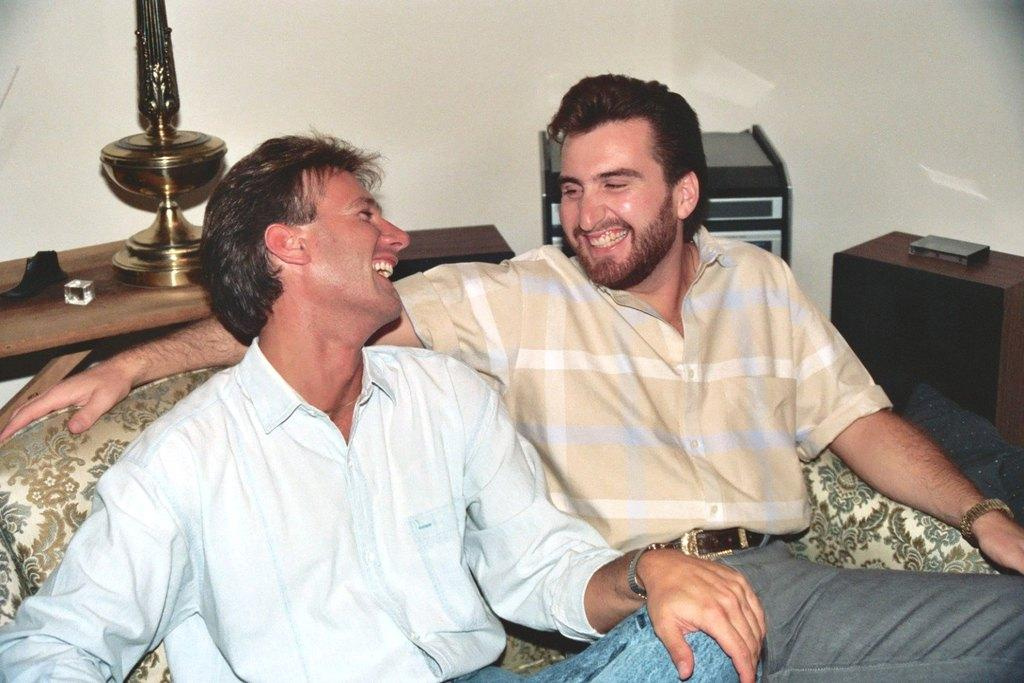How many people are in the image? There are two men in the image. What are the men doing in the image? The men are sitting on a sofa and smiling. What is on the table in the image? There are dice on the table. What can be seen in the background of the image? There is a wall in the background of the image. What type of battle is taking place in the image? There is no battle present in the image; it features two men sitting on a sofa and smiling. What color is the jar on the table in the image? There is no jar present on the table in the image; it features dice instead. 